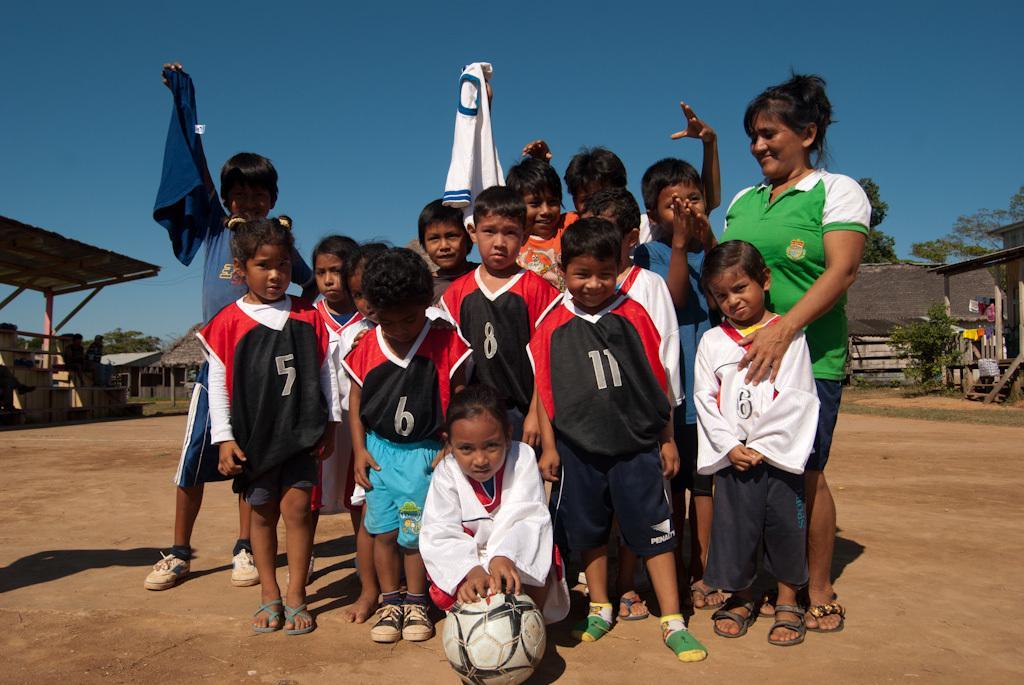Can you describe this image briefly? In the center of the image we can see people standing. At the bottom there is a wall. In the background there are sheds, trees and sky. 